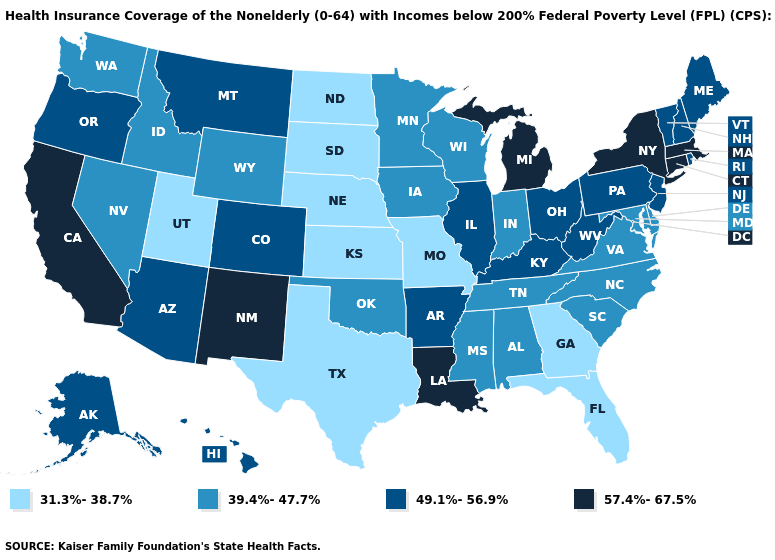Name the states that have a value in the range 31.3%-38.7%?
Answer briefly. Florida, Georgia, Kansas, Missouri, Nebraska, North Dakota, South Dakota, Texas, Utah. Among the states that border Massachusetts , which have the lowest value?
Write a very short answer. New Hampshire, Rhode Island, Vermont. Is the legend a continuous bar?
Write a very short answer. No. What is the lowest value in states that border Texas?
Concise answer only. 39.4%-47.7%. Does Nebraska have a higher value than Kansas?
Be succinct. No. What is the lowest value in the USA?
Short answer required. 31.3%-38.7%. What is the lowest value in states that border Louisiana?
Keep it brief. 31.3%-38.7%. What is the value of Indiana?
Be succinct. 39.4%-47.7%. Among the states that border Nebraska , does Kansas have the highest value?
Short answer required. No. Does the first symbol in the legend represent the smallest category?
Keep it brief. Yes. Which states hav the highest value in the Northeast?
Write a very short answer. Connecticut, Massachusetts, New York. Does the map have missing data?
Write a very short answer. No. What is the highest value in the USA?
Short answer required. 57.4%-67.5%. What is the lowest value in the West?
Quick response, please. 31.3%-38.7%. What is the highest value in the USA?
Answer briefly. 57.4%-67.5%. 